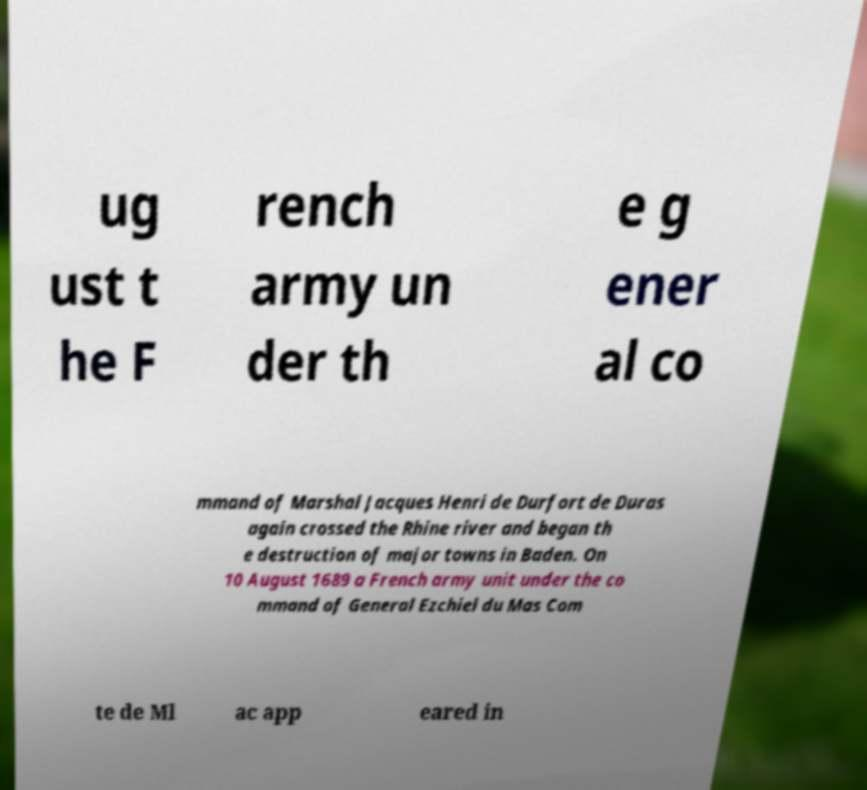Could you assist in decoding the text presented in this image and type it out clearly? ug ust t he F rench army un der th e g ener al co mmand of Marshal Jacques Henri de Durfort de Duras again crossed the Rhine river and began th e destruction of major towns in Baden. On 10 August 1689 a French army unit under the co mmand of General Ezchiel du Mas Com te de Ml ac app eared in 